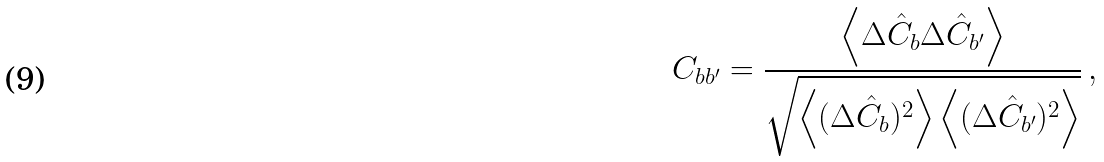Convert formula to latex. <formula><loc_0><loc_0><loc_500><loc_500>C _ { b b ^ { \prime } } = \frac { \left < \Delta \hat { C } _ { b } \Delta \hat { C } _ { b ^ { \prime } } \right > } { \sqrt { \left < ( \Delta \hat { C } _ { b } ) ^ { 2 } \right > \left < ( \Delta \hat { C } _ { b ^ { \prime } } ) ^ { 2 } \right > } } \, ,</formula> 